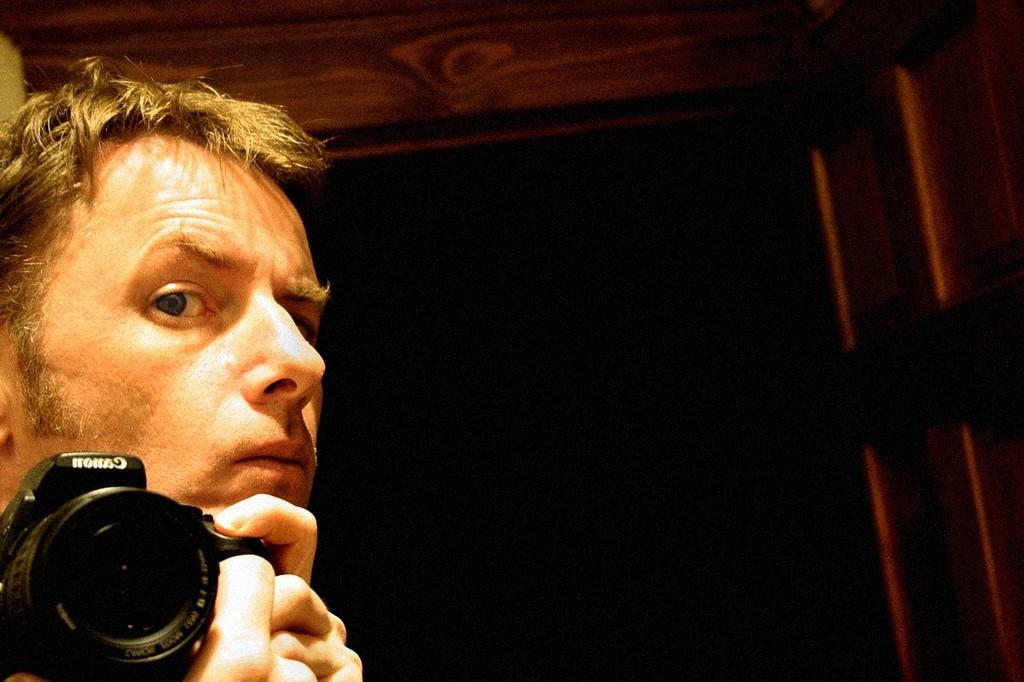What is the main subject of the image? There is a person in the image. What is the person holding in the image? The person is holding a camera. How many beds can be seen in the image? There are no beds present in the image. What type of print is visible on the person's shirt in the image? The person's shirt is not visible in the image, so it is not possible to determine the type of print. 